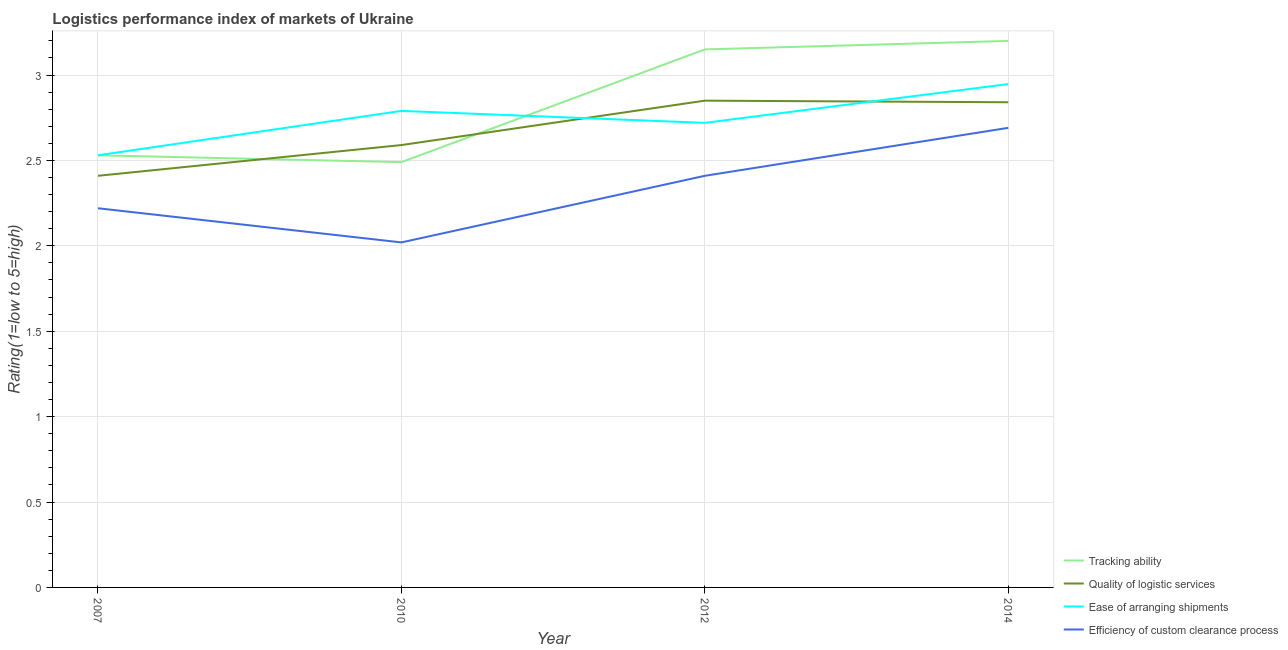Is the number of lines equal to the number of legend labels?
Your answer should be very brief. Yes. What is the lpi rating of efficiency of custom clearance process in 2010?
Keep it short and to the point. 2.02. Across all years, what is the maximum lpi rating of quality of logistic services?
Offer a terse response. 2.85. Across all years, what is the minimum lpi rating of tracking ability?
Your answer should be compact. 2.49. In which year was the lpi rating of quality of logistic services minimum?
Your response must be concise. 2007. What is the total lpi rating of quality of logistic services in the graph?
Your answer should be very brief. 10.69. What is the difference between the lpi rating of tracking ability in 2007 and that in 2014?
Your answer should be compact. -0.67. What is the difference between the lpi rating of efficiency of custom clearance process in 2014 and the lpi rating of tracking ability in 2007?
Your response must be concise. 0.16. What is the average lpi rating of quality of logistic services per year?
Provide a short and direct response. 2.67. In the year 2014, what is the difference between the lpi rating of efficiency of custom clearance process and lpi rating of quality of logistic services?
Provide a succinct answer. -0.15. In how many years, is the lpi rating of quality of logistic services greater than 1.1?
Provide a succinct answer. 4. What is the ratio of the lpi rating of efficiency of custom clearance process in 2010 to that in 2014?
Give a very brief answer. 0.75. Is the lpi rating of tracking ability in 2007 less than that in 2010?
Provide a succinct answer. No. What is the difference between the highest and the second highest lpi rating of tracking ability?
Provide a short and direct response. 0.05. What is the difference between the highest and the lowest lpi rating of efficiency of custom clearance process?
Provide a succinct answer. 0.67. In how many years, is the lpi rating of efficiency of custom clearance process greater than the average lpi rating of efficiency of custom clearance process taken over all years?
Keep it short and to the point. 2. Is it the case that in every year, the sum of the lpi rating of tracking ability and lpi rating of quality of logistic services is greater than the lpi rating of ease of arranging shipments?
Your answer should be compact. Yes. Is the lpi rating of efficiency of custom clearance process strictly less than the lpi rating of quality of logistic services over the years?
Provide a succinct answer. Yes. How many lines are there?
Your answer should be very brief. 4. How many years are there in the graph?
Keep it short and to the point. 4. What is the difference between two consecutive major ticks on the Y-axis?
Your response must be concise. 0.5. Are the values on the major ticks of Y-axis written in scientific E-notation?
Make the answer very short. No. Does the graph contain any zero values?
Ensure brevity in your answer.  No. How are the legend labels stacked?
Ensure brevity in your answer.  Vertical. What is the title of the graph?
Offer a very short reply. Logistics performance index of markets of Ukraine. Does "Salary of employees" appear as one of the legend labels in the graph?
Provide a succinct answer. No. What is the label or title of the Y-axis?
Ensure brevity in your answer.  Rating(1=low to 5=high). What is the Rating(1=low to 5=high) of Tracking ability in 2007?
Offer a terse response. 2.53. What is the Rating(1=low to 5=high) of Quality of logistic services in 2007?
Keep it short and to the point. 2.41. What is the Rating(1=low to 5=high) of Ease of arranging shipments in 2007?
Offer a very short reply. 2.53. What is the Rating(1=low to 5=high) in Efficiency of custom clearance process in 2007?
Offer a very short reply. 2.22. What is the Rating(1=low to 5=high) in Tracking ability in 2010?
Make the answer very short. 2.49. What is the Rating(1=low to 5=high) of Quality of logistic services in 2010?
Give a very brief answer. 2.59. What is the Rating(1=low to 5=high) of Ease of arranging shipments in 2010?
Offer a very short reply. 2.79. What is the Rating(1=low to 5=high) of Efficiency of custom clearance process in 2010?
Your answer should be compact. 2.02. What is the Rating(1=low to 5=high) in Tracking ability in 2012?
Offer a very short reply. 3.15. What is the Rating(1=low to 5=high) of Quality of logistic services in 2012?
Your response must be concise. 2.85. What is the Rating(1=low to 5=high) in Ease of arranging shipments in 2012?
Make the answer very short. 2.72. What is the Rating(1=low to 5=high) of Efficiency of custom clearance process in 2012?
Your answer should be compact. 2.41. What is the Rating(1=low to 5=high) of Tracking ability in 2014?
Keep it short and to the point. 3.2. What is the Rating(1=low to 5=high) in Quality of logistic services in 2014?
Your answer should be very brief. 2.84. What is the Rating(1=low to 5=high) of Ease of arranging shipments in 2014?
Make the answer very short. 2.95. What is the Rating(1=low to 5=high) in Efficiency of custom clearance process in 2014?
Ensure brevity in your answer.  2.69. Across all years, what is the maximum Rating(1=low to 5=high) of Tracking ability?
Provide a short and direct response. 3.2. Across all years, what is the maximum Rating(1=low to 5=high) of Quality of logistic services?
Provide a succinct answer. 2.85. Across all years, what is the maximum Rating(1=low to 5=high) in Ease of arranging shipments?
Ensure brevity in your answer.  2.95. Across all years, what is the maximum Rating(1=low to 5=high) of Efficiency of custom clearance process?
Provide a succinct answer. 2.69. Across all years, what is the minimum Rating(1=low to 5=high) in Tracking ability?
Give a very brief answer. 2.49. Across all years, what is the minimum Rating(1=low to 5=high) in Quality of logistic services?
Offer a very short reply. 2.41. Across all years, what is the minimum Rating(1=low to 5=high) in Ease of arranging shipments?
Make the answer very short. 2.53. Across all years, what is the minimum Rating(1=low to 5=high) of Efficiency of custom clearance process?
Your answer should be compact. 2.02. What is the total Rating(1=low to 5=high) in Tracking ability in the graph?
Provide a short and direct response. 11.37. What is the total Rating(1=low to 5=high) in Quality of logistic services in the graph?
Provide a succinct answer. 10.69. What is the total Rating(1=low to 5=high) in Ease of arranging shipments in the graph?
Ensure brevity in your answer.  10.99. What is the total Rating(1=low to 5=high) in Efficiency of custom clearance process in the graph?
Ensure brevity in your answer.  9.34. What is the difference between the Rating(1=low to 5=high) of Tracking ability in 2007 and that in 2010?
Your response must be concise. 0.04. What is the difference between the Rating(1=low to 5=high) of Quality of logistic services in 2007 and that in 2010?
Make the answer very short. -0.18. What is the difference between the Rating(1=low to 5=high) in Ease of arranging shipments in 2007 and that in 2010?
Ensure brevity in your answer.  -0.26. What is the difference between the Rating(1=low to 5=high) of Efficiency of custom clearance process in 2007 and that in 2010?
Ensure brevity in your answer.  0.2. What is the difference between the Rating(1=low to 5=high) in Tracking ability in 2007 and that in 2012?
Keep it short and to the point. -0.62. What is the difference between the Rating(1=low to 5=high) of Quality of logistic services in 2007 and that in 2012?
Ensure brevity in your answer.  -0.44. What is the difference between the Rating(1=low to 5=high) of Ease of arranging shipments in 2007 and that in 2012?
Your answer should be compact. -0.19. What is the difference between the Rating(1=low to 5=high) of Efficiency of custom clearance process in 2007 and that in 2012?
Provide a short and direct response. -0.19. What is the difference between the Rating(1=low to 5=high) in Tracking ability in 2007 and that in 2014?
Offer a very short reply. -0.67. What is the difference between the Rating(1=low to 5=high) in Quality of logistic services in 2007 and that in 2014?
Keep it short and to the point. -0.43. What is the difference between the Rating(1=low to 5=high) of Ease of arranging shipments in 2007 and that in 2014?
Ensure brevity in your answer.  -0.42. What is the difference between the Rating(1=low to 5=high) in Efficiency of custom clearance process in 2007 and that in 2014?
Make the answer very short. -0.47. What is the difference between the Rating(1=low to 5=high) in Tracking ability in 2010 and that in 2012?
Give a very brief answer. -0.66. What is the difference between the Rating(1=low to 5=high) of Quality of logistic services in 2010 and that in 2012?
Provide a short and direct response. -0.26. What is the difference between the Rating(1=low to 5=high) in Ease of arranging shipments in 2010 and that in 2012?
Give a very brief answer. 0.07. What is the difference between the Rating(1=low to 5=high) in Efficiency of custom clearance process in 2010 and that in 2012?
Your answer should be compact. -0.39. What is the difference between the Rating(1=low to 5=high) in Tracking ability in 2010 and that in 2014?
Give a very brief answer. -0.71. What is the difference between the Rating(1=low to 5=high) in Quality of logistic services in 2010 and that in 2014?
Your answer should be compact. -0.25. What is the difference between the Rating(1=low to 5=high) in Ease of arranging shipments in 2010 and that in 2014?
Your answer should be very brief. -0.16. What is the difference between the Rating(1=low to 5=high) of Efficiency of custom clearance process in 2010 and that in 2014?
Offer a terse response. -0.67. What is the difference between the Rating(1=low to 5=high) of Tracking ability in 2012 and that in 2014?
Provide a short and direct response. -0.05. What is the difference between the Rating(1=low to 5=high) of Quality of logistic services in 2012 and that in 2014?
Ensure brevity in your answer.  0.01. What is the difference between the Rating(1=low to 5=high) in Ease of arranging shipments in 2012 and that in 2014?
Provide a succinct answer. -0.23. What is the difference between the Rating(1=low to 5=high) of Efficiency of custom clearance process in 2012 and that in 2014?
Your response must be concise. -0.28. What is the difference between the Rating(1=low to 5=high) in Tracking ability in 2007 and the Rating(1=low to 5=high) in Quality of logistic services in 2010?
Your answer should be compact. -0.06. What is the difference between the Rating(1=low to 5=high) in Tracking ability in 2007 and the Rating(1=low to 5=high) in Ease of arranging shipments in 2010?
Offer a very short reply. -0.26. What is the difference between the Rating(1=low to 5=high) of Tracking ability in 2007 and the Rating(1=low to 5=high) of Efficiency of custom clearance process in 2010?
Offer a very short reply. 0.51. What is the difference between the Rating(1=low to 5=high) of Quality of logistic services in 2007 and the Rating(1=low to 5=high) of Ease of arranging shipments in 2010?
Your response must be concise. -0.38. What is the difference between the Rating(1=low to 5=high) of Quality of logistic services in 2007 and the Rating(1=low to 5=high) of Efficiency of custom clearance process in 2010?
Your response must be concise. 0.39. What is the difference between the Rating(1=low to 5=high) in Ease of arranging shipments in 2007 and the Rating(1=low to 5=high) in Efficiency of custom clearance process in 2010?
Provide a short and direct response. 0.51. What is the difference between the Rating(1=low to 5=high) in Tracking ability in 2007 and the Rating(1=low to 5=high) in Quality of logistic services in 2012?
Offer a terse response. -0.32. What is the difference between the Rating(1=low to 5=high) of Tracking ability in 2007 and the Rating(1=low to 5=high) of Ease of arranging shipments in 2012?
Ensure brevity in your answer.  -0.19. What is the difference between the Rating(1=low to 5=high) in Tracking ability in 2007 and the Rating(1=low to 5=high) in Efficiency of custom clearance process in 2012?
Offer a terse response. 0.12. What is the difference between the Rating(1=low to 5=high) of Quality of logistic services in 2007 and the Rating(1=low to 5=high) of Ease of arranging shipments in 2012?
Provide a short and direct response. -0.31. What is the difference between the Rating(1=low to 5=high) of Ease of arranging shipments in 2007 and the Rating(1=low to 5=high) of Efficiency of custom clearance process in 2012?
Provide a succinct answer. 0.12. What is the difference between the Rating(1=low to 5=high) in Tracking ability in 2007 and the Rating(1=low to 5=high) in Quality of logistic services in 2014?
Offer a terse response. -0.31. What is the difference between the Rating(1=low to 5=high) of Tracking ability in 2007 and the Rating(1=low to 5=high) of Ease of arranging shipments in 2014?
Your response must be concise. -0.42. What is the difference between the Rating(1=low to 5=high) of Tracking ability in 2007 and the Rating(1=low to 5=high) of Efficiency of custom clearance process in 2014?
Keep it short and to the point. -0.16. What is the difference between the Rating(1=low to 5=high) in Quality of logistic services in 2007 and the Rating(1=low to 5=high) in Ease of arranging shipments in 2014?
Ensure brevity in your answer.  -0.54. What is the difference between the Rating(1=low to 5=high) in Quality of logistic services in 2007 and the Rating(1=low to 5=high) in Efficiency of custom clearance process in 2014?
Keep it short and to the point. -0.28. What is the difference between the Rating(1=low to 5=high) in Ease of arranging shipments in 2007 and the Rating(1=low to 5=high) in Efficiency of custom clearance process in 2014?
Make the answer very short. -0.16. What is the difference between the Rating(1=low to 5=high) of Tracking ability in 2010 and the Rating(1=low to 5=high) of Quality of logistic services in 2012?
Keep it short and to the point. -0.36. What is the difference between the Rating(1=low to 5=high) of Tracking ability in 2010 and the Rating(1=low to 5=high) of Ease of arranging shipments in 2012?
Give a very brief answer. -0.23. What is the difference between the Rating(1=low to 5=high) in Tracking ability in 2010 and the Rating(1=low to 5=high) in Efficiency of custom clearance process in 2012?
Your answer should be very brief. 0.08. What is the difference between the Rating(1=low to 5=high) of Quality of logistic services in 2010 and the Rating(1=low to 5=high) of Ease of arranging shipments in 2012?
Keep it short and to the point. -0.13. What is the difference between the Rating(1=low to 5=high) in Quality of logistic services in 2010 and the Rating(1=low to 5=high) in Efficiency of custom clearance process in 2012?
Ensure brevity in your answer.  0.18. What is the difference between the Rating(1=low to 5=high) of Ease of arranging shipments in 2010 and the Rating(1=low to 5=high) of Efficiency of custom clearance process in 2012?
Provide a succinct answer. 0.38. What is the difference between the Rating(1=low to 5=high) of Tracking ability in 2010 and the Rating(1=low to 5=high) of Quality of logistic services in 2014?
Your answer should be compact. -0.35. What is the difference between the Rating(1=low to 5=high) of Tracking ability in 2010 and the Rating(1=low to 5=high) of Ease of arranging shipments in 2014?
Make the answer very short. -0.46. What is the difference between the Rating(1=low to 5=high) of Tracking ability in 2010 and the Rating(1=low to 5=high) of Efficiency of custom clearance process in 2014?
Give a very brief answer. -0.2. What is the difference between the Rating(1=low to 5=high) in Quality of logistic services in 2010 and the Rating(1=low to 5=high) in Ease of arranging shipments in 2014?
Provide a short and direct response. -0.36. What is the difference between the Rating(1=low to 5=high) of Quality of logistic services in 2010 and the Rating(1=low to 5=high) of Efficiency of custom clearance process in 2014?
Keep it short and to the point. -0.1. What is the difference between the Rating(1=low to 5=high) in Ease of arranging shipments in 2010 and the Rating(1=low to 5=high) in Efficiency of custom clearance process in 2014?
Provide a succinct answer. 0.1. What is the difference between the Rating(1=low to 5=high) of Tracking ability in 2012 and the Rating(1=low to 5=high) of Quality of logistic services in 2014?
Provide a succinct answer. 0.31. What is the difference between the Rating(1=low to 5=high) of Tracking ability in 2012 and the Rating(1=low to 5=high) of Ease of arranging shipments in 2014?
Provide a short and direct response. 0.2. What is the difference between the Rating(1=low to 5=high) of Tracking ability in 2012 and the Rating(1=low to 5=high) of Efficiency of custom clearance process in 2014?
Your answer should be very brief. 0.46. What is the difference between the Rating(1=low to 5=high) of Quality of logistic services in 2012 and the Rating(1=low to 5=high) of Ease of arranging shipments in 2014?
Ensure brevity in your answer.  -0.1. What is the difference between the Rating(1=low to 5=high) in Quality of logistic services in 2012 and the Rating(1=low to 5=high) in Efficiency of custom clearance process in 2014?
Give a very brief answer. 0.16. What is the difference between the Rating(1=low to 5=high) in Ease of arranging shipments in 2012 and the Rating(1=low to 5=high) in Efficiency of custom clearance process in 2014?
Give a very brief answer. 0.03. What is the average Rating(1=low to 5=high) of Tracking ability per year?
Your response must be concise. 2.84. What is the average Rating(1=low to 5=high) in Quality of logistic services per year?
Provide a short and direct response. 2.67. What is the average Rating(1=low to 5=high) in Ease of arranging shipments per year?
Provide a succinct answer. 2.75. What is the average Rating(1=low to 5=high) of Efficiency of custom clearance process per year?
Provide a succinct answer. 2.34. In the year 2007, what is the difference between the Rating(1=low to 5=high) of Tracking ability and Rating(1=low to 5=high) of Quality of logistic services?
Keep it short and to the point. 0.12. In the year 2007, what is the difference between the Rating(1=low to 5=high) in Tracking ability and Rating(1=low to 5=high) in Efficiency of custom clearance process?
Provide a succinct answer. 0.31. In the year 2007, what is the difference between the Rating(1=low to 5=high) of Quality of logistic services and Rating(1=low to 5=high) of Ease of arranging shipments?
Make the answer very short. -0.12. In the year 2007, what is the difference between the Rating(1=low to 5=high) in Quality of logistic services and Rating(1=low to 5=high) in Efficiency of custom clearance process?
Your answer should be very brief. 0.19. In the year 2007, what is the difference between the Rating(1=low to 5=high) in Ease of arranging shipments and Rating(1=low to 5=high) in Efficiency of custom clearance process?
Offer a very short reply. 0.31. In the year 2010, what is the difference between the Rating(1=low to 5=high) of Tracking ability and Rating(1=low to 5=high) of Ease of arranging shipments?
Make the answer very short. -0.3. In the year 2010, what is the difference between the Rating(1=low to 5=high) in Tracking ability and Rating(1=low to 5=high) in Efficiency of custom clearance process?
Provide a short and direct response. 0.47. In the year 2010, what is the difference between the Rating(1=low to 5=high) in Quality of logistic services and Rating(1=low to 5=high) in Efficiency of custom clearance process?
Provide a succinct answer. 0.57. In the year 2010, what is the difference between the Rating(1=low to 5=high) in Ease of arranging shipments and Rating(1=low to 5=high) in Efficiency of custom clearance process?
Your answer should be very brief. 0.77. In the year 2012, what is the difference between the Rating(1=low to 5=high) of Tracking ability and Rating(1=low to 5=high) of Quality of logistic services?
Give a very brief answer. 0.3. In the year 2012, what is the difference between the Rating(1=low to 5=high) of Tracking ability and Rating(1=low to 5=high) of Ease of arranging shipments?
Ensure brevity in your answer.  0.43. In the year 2012, what is the difference between the Rating(1=low to 5=high) in Tracking ability and Rating(1=low to 5=high) in Efficiency of custom clearance process?
Ensure brevity in your answer.  0.74. In the year 2012, what is the difference between the Rating(1=low to 5=high) in Quality of logistic services and Rating(1=low to 5=high) in Ease of arranging shipments?
Provide a succinct answer. 0.13. In the year 2012, what is the difference between the Rating(1=low to 5=high) in Quality of logistic services and Rating(1=low to 5=high) in Efficiency of custom clearance process?
Your answer should be very brief. 0.44. In the year 2012, what is the difference between the Rating(1=low to 5=high) in Ease of arranging shipments and Rating(1=low to 5=high) in Efficiency of custom clearance process?
Provide a succinct answer. 0.31. In the year 2014, what is the difference between the Rating(1=low to 5=high) in Tracking ability and Rating(1=low to 5=high) in Quality of logistic services?
Give a very brief answer. 0.36. In the year 2014, what is the difference between the Rating(1=low to 5=high) in Tracking ability and Rating(1=low to 5=high) in Ease of arranging shipments?
Offer a very short reply. 0.25. In the year 2014, what is the difference between the Rating(1=low to 5=high) in Tracking ability and Rating(1=low to 5=high) in Efficiency of custom clearance process?
Make the answer very short. 0.51. In the year 2014, what is the difference between the Rating(1=low to 5=high) of Quality of logistic services and Rating(1=low to 5=high) of Ease of arranging shipments?
Your response must be concise. -0.11. In the year 2014, what is the difference between the Rating(1=low to 5=high) of Quality of logistic services and Rating(1=low to 5=high) of Efficiency of custom clearance process?
Ensure brevity in your answer.  0.15. In the year 2014, what is the difference between the Rating(1=low to 5=high) in Ease of arranging shipments and Rating(1=low to 5=high) in Efficiency of custom clearance process?
Make the answer very short. 0.26. What is the ratio of the Rating(1=low to 5=high) of Tracking ability in 2007 to that in 2010?
Make the answer very short. 1.02. What is the ratio of the Rating(1=low to 5=high) of Quality of logistic services in 2007 to that in 2010?
Keep it short and to the point. 0.93. What is the ratio of the Rating(1=low to 5=high) of Ease of arranging shipments in 2007 to that in 2010?
Give a very brief answer. 0.91. What is the ratio of the Rating(1=low to 5=high) of Efficiency of custom clearance process in 2007 to that in 2010?
Your answer should be compact. 1.1. What is the ratio of the Rating(1=low to 5=high) of Tracking ability in 2007 to that in 2012?
Provide a succinct answer. 0.8. What is the ratio of the Rating(1=low to 5=high) in Quality of logistic services in 2007 to that in 2012?
Keep it short and to the point. 0.85. What is the ratio of the Rating(1=low to 5=high) of Ease of arranging shipments in 2007 to that in 2012?
Offer a terse response. 0.93. What is the ratio of the Rating(1=low to 5=high) in Efficiency of custom clearance process in 2007 to that in 2012?
Provide a short and direct response. 0.92. What is the ratio of the Rating(1=low to 5=high) in Tracking ability in 2007 to that in 2014?
Give a very brief answer. 0.79. What is the ratio of the Rating(1=low to 5=high) in Quality of logistic services in 2007 to that in 2014?
Your response must be concise. 0.85. What is the ratio of the Rating(1=low to 5=high) in Ease of arranging shipments in 2007 to that in 2014?
Give a very brief answer. 0.86. What is the ratio of the Rating(1=low to 5=high) in Efficiency of custom clearance process in 2007 to that in 2014?
Your answer should be very brief. 0.82. What is the ratio of the Rating(1=low to 5=high) in Tracking ability in 2010 to that in 2012?
Offer a very short reply. 0.79. What is the ratio of the Rating(1=low to 5=high) in Quality of logistic services in 2010 to that in 2012?
Your response must be concise. 0.91. What is the ratio of the Rating(1=low to 5=high) in Ease of arranging shipments in 2010 to that in 2012?
Give a very brief answer. 1.03. What is the ratio of the Rating(1=low to 5=high) in Efficiency of custom clearance process in 2010 to that in 2012?
Your response must be concise. 0.84. What is the ratio of the Rating(1=low to 5=high) of Tracking ability in 2010 to that in 2014?
Ensure brevity in your answer.  0.78. What is the ratio of the Rating(1=low to 5=high) of Quality of logistic services in 2010 to that in 2014?
Your response must be concise. 0.91. What is the ratio of the Rating(1=low to 5=high) of Ease of arranging shipments in 2010 to that in 2014?
Provide a short and direct response. 0.95. What is the ratio of the Rating(1=low to 5=high) of Efficiency of custom clearance process in 2010 to that in 2014?
Keep it short and to the point. 0.75. What is the ratio of the Rating(1=low to 5=high) of Tracking ability in 2012 to that in 2014?
Your response must be concise. 0.98. What is the ratio of the Rating(1=low to 5=high) in Quality of logistic services in 2012 to that in 2014?
Your answer should be very brief. 1. What is the ratio of the Rating(1=low to 5=high) in Ease of arranging shipments in 2012 to that in 2014?
Your answer should be very brief. 0.92. What is the ratio of the Rating(1=low to 5=high) of Efficiency of custom clearance process in 2012 to that in 2014?
Offer a very short reply. 0.9. What is the difference between the highest and the second highest Rating(1=low to 5=high) of Tracking ability?
Offer a terse response. 0.05. What is the difference between the highest and the second highest Rating(1=low to 5=high) of Quality of logistic services?
Offer a terse response. 0.01. What is the difference between the highest and the second highest Rating(1=low to 5=high) in Ease of arranging shipments?
Give a very brief answer. 0.16. What is the difference between the highest and the second highest Rating(1=low to 5=high) of Efficiency of custom clearance process?
Offer a very short reply. 0.28. What is the difference between the highest and the lowest Rating(1=low to 5=high) of Tracking ability?
Ensure brevity in your answer.  0.71. What is the difference between the highest and the lowest Rating(1=low to 5=high) in Quality of logistic services?
Your answer should be compact. 0.44. What is the difference between the highest and the lowest Rating(1=low to 5=high) of Ease of arranging shipments?
Your response must be concise. 0.42. What is the difference between the highest and the lowest Rating(1=low to 5=high) in Efficiency of custom clearance process?
Offer a terse response. 0.67. 